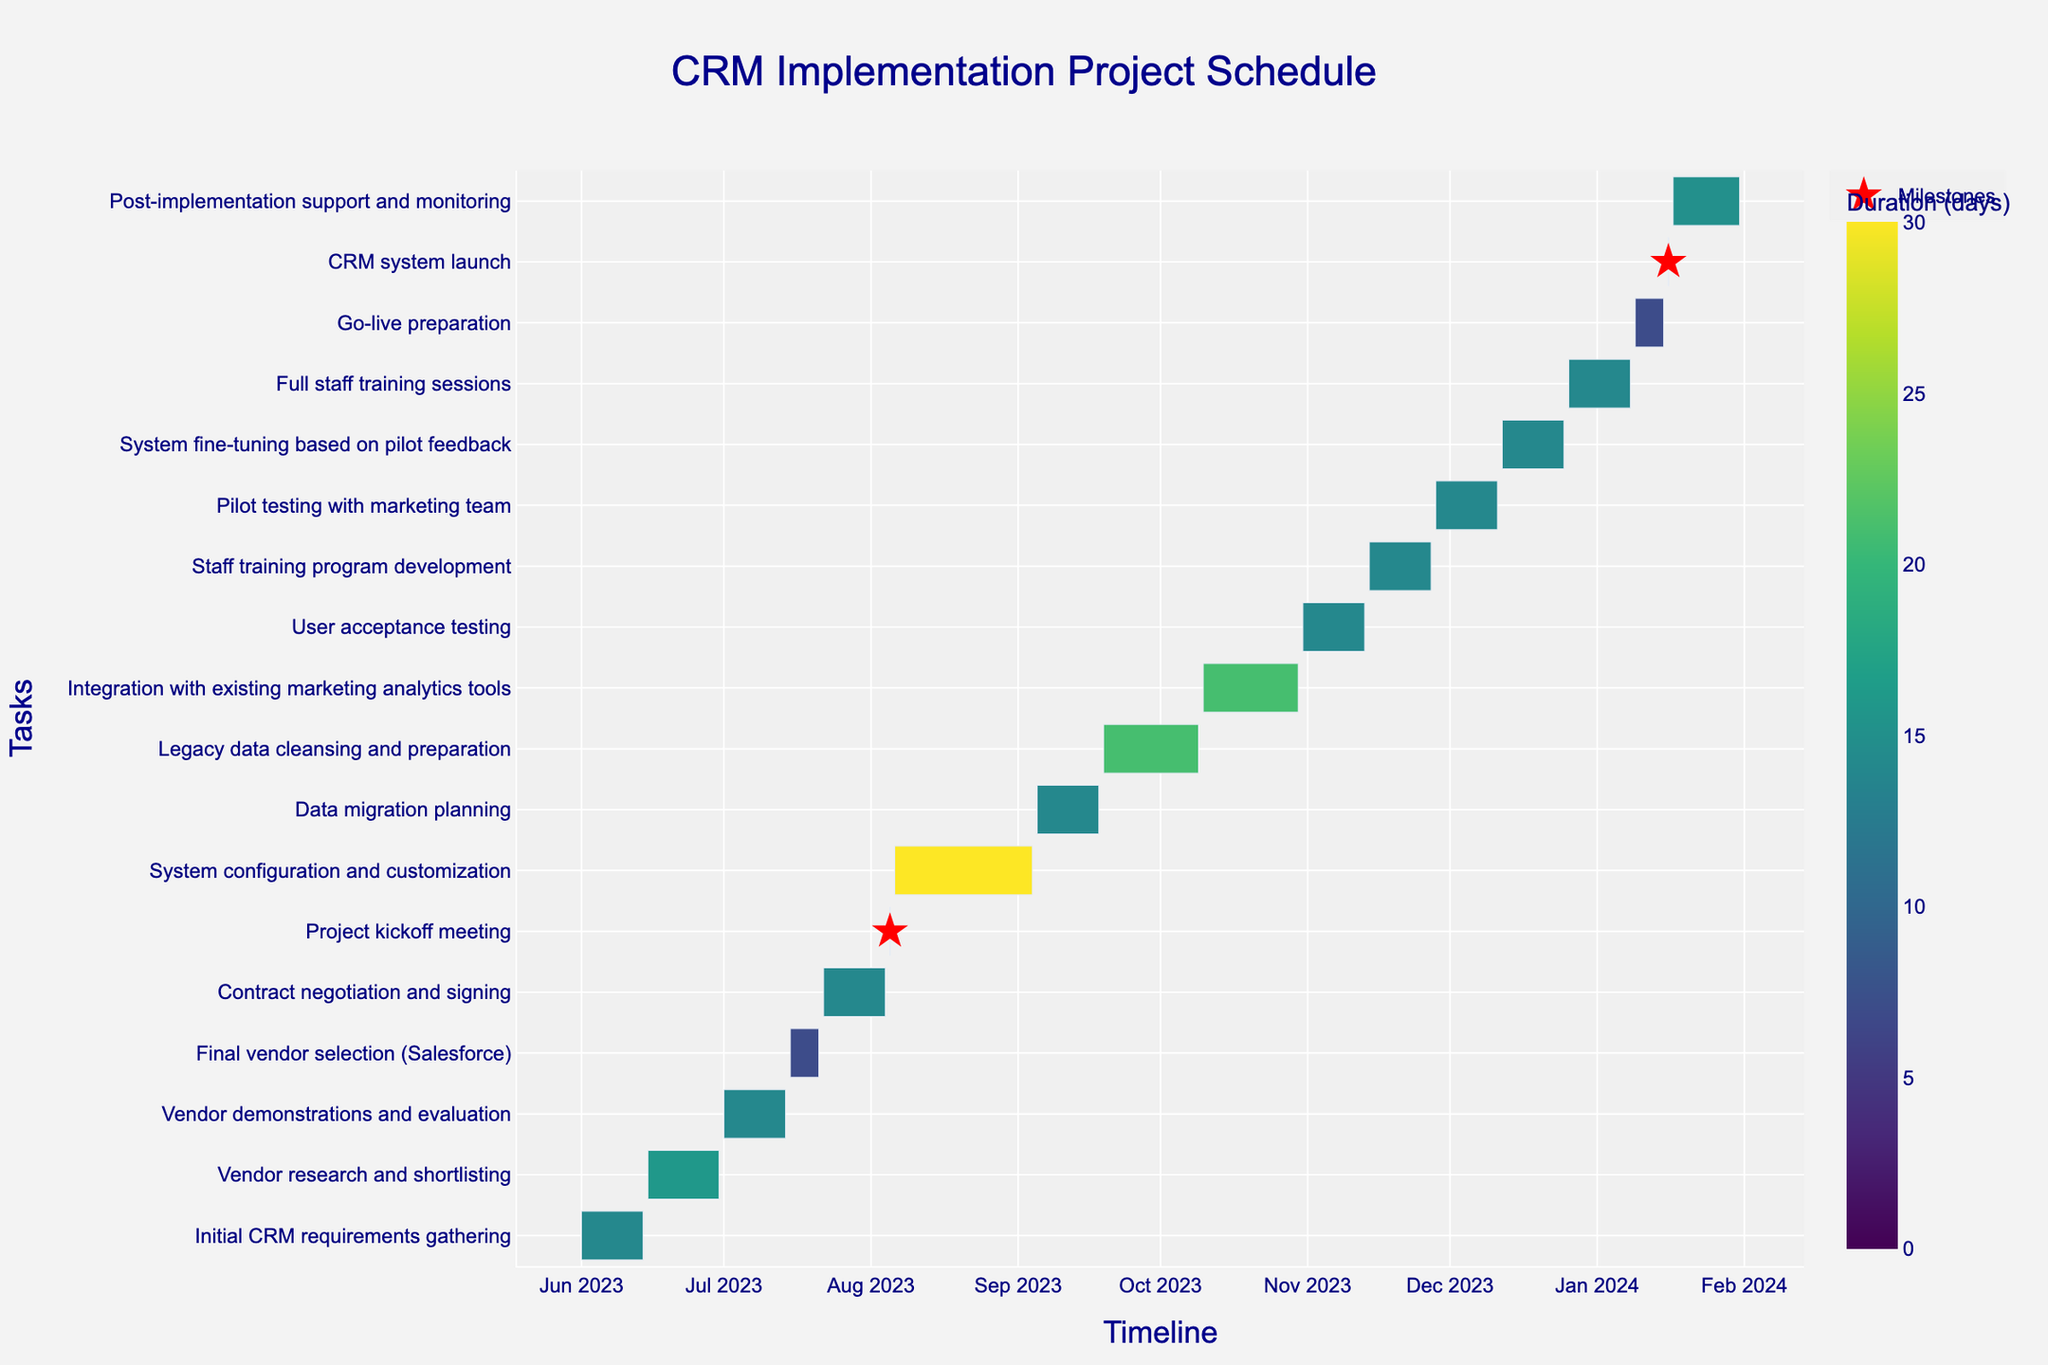What is the title of the Gantt chart? The title of the Gantt chart is displayed at the top center of the chart.
Answer: CRM Implementation Project Schedule What is the first task listed in the project schedule? The first task listed in the project is positioned at the top of the y-axis.
Answer: Initial CRM requirements gathering How long does the "Vendor research and shortlisting" task take? The color bar indicates duration. The task is color-coded, which matches up with its value on the color scale.
Answer: 16 days Which task has the shortest duration? Milestones are shown with red star symbols and have a duration of 1 day. The task names next to these symbols indicate tasks with one-day durations.
Answer: Project kickoff meeting and CRM system launch How many tasks are scheduled to be completed by the end of August 2023? Analyzing the x-axis for timeline data, count the tasks that end on or before August 31, 2023.
Answer: Six tasks What tasks overlap with the "System configuration and customization" task? Identify the tasks that have start and/or end dates falling within the start and end dates of the "System configuration and customization" task.
Answer: Project kickoff meeting and Data migration planning How long is the "Post-implementation support and monitoring" task? By examining the duration label on the color bar and matching it to the specific task.
Answer: 15 days Which task takes place from June 15 to June 30, 2023? Refer to the tasks aligned with the specified date range on the x-axis.
Answer: Vendor research and shortlisting What is the difference in duration between "Contract negotiation and signing" and "Full staff training sessions"? Subtract the duration of the two tasks as indicated on the color bar. Contract negotiation and signing: 14 days, Full staff training sessions: 14 days, Difference: 14 - 14 = 0
Answer: 0 days Which task immediately follows "Legacy data cleansing and preparation"? Refer to the task that starts right after the "Legacy data cleansing and preparation" task on the y-axis.
Answer: Integration with existing marketing analytics tools 